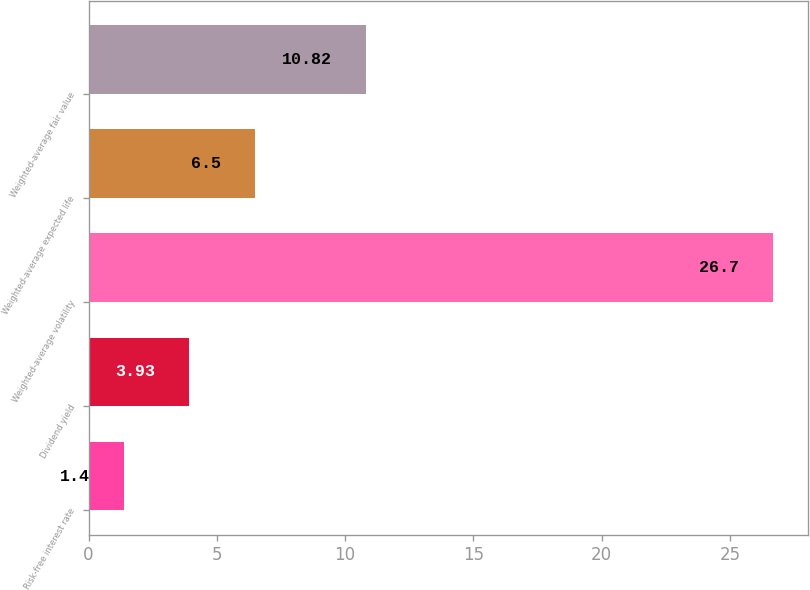Convert chart to OTSL. <chart><loc_0><loc_0><loc_500><loc_500><bar_chart><fcel>Risk-free interest rate<fcel>Dividend yield<fcel>Weighted-average volatility<fcel>Weighted-average expected life<fcel>Weighted-average fair value<nl><fcel>1.4<fcel>3.93<fcel>26.7<fcel>6.5<fcel>10.82<nl></chart> 